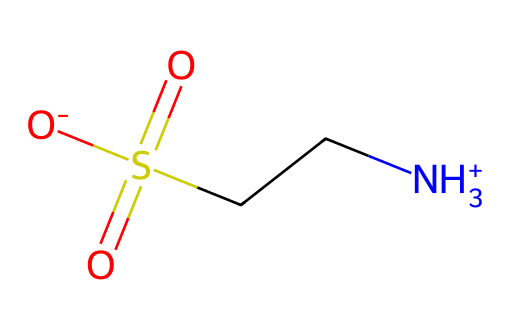What is the IUPAC name of this compound? The SMILES representation indicates the presence of the amino group (NH3+), the ethyl group (C), and the sulfonic acid group (S(=O)(=O)[O-]). Combining these functional groups gives the IUPAC name of 2-aminoethanesulfonic acid, commonly known as taurine.
Answer: 2-aminoethanesulfonic acid How many carbon atoms are present in taurine? Analyzing the SMILES representation, there is one carbon atom attached to the amino group and another carbon atom attached to the sulfonic acid group, totaling two carbon atoms in the structure.
Answer: two What type of functional groups are found in taurine? The SMILES shows the presence of an amino group (NH3+), which is characteristic of amines, and a sulfonic acid group (S(=O)(=O)[O-]), indicating taurine is a sulfonic acid. Therefore, taurine has an amine functional group and a sulfonic acid functional group.
Answer: amine and sulfonic acid Is taurine an ionic or covalent compound? The presence of the charged amino group (NH3+) indicates ionic characteristics, while the overall structure suggests covalent bonding between the atoms. However, taurine is often found in protonated forms in solution, leading to ionic interactions. Thus, it can behave as an ionic compound in some contexts but is fundamentally covalent in structure.
Answer: both What is the net charge of taurine? By analyzing the SMILES notation, the ammonium (NH3+) contributes a positive charge and the sulfonate (S(=O)(=O)[O-]) contributes a negative charge. Therefore, the net charge is neutral (as one positive and one negative charge balance each other out).
Answer: neutral What role does taurine play in energy drinks? Taurine is often included in energy drinks due to its purported benefits in improving mental performance, reducing fatigue, and supporting cardiovascular health, making it appealing to gamers seeking enhanced gaming performance.
Answer: energy enhancer 